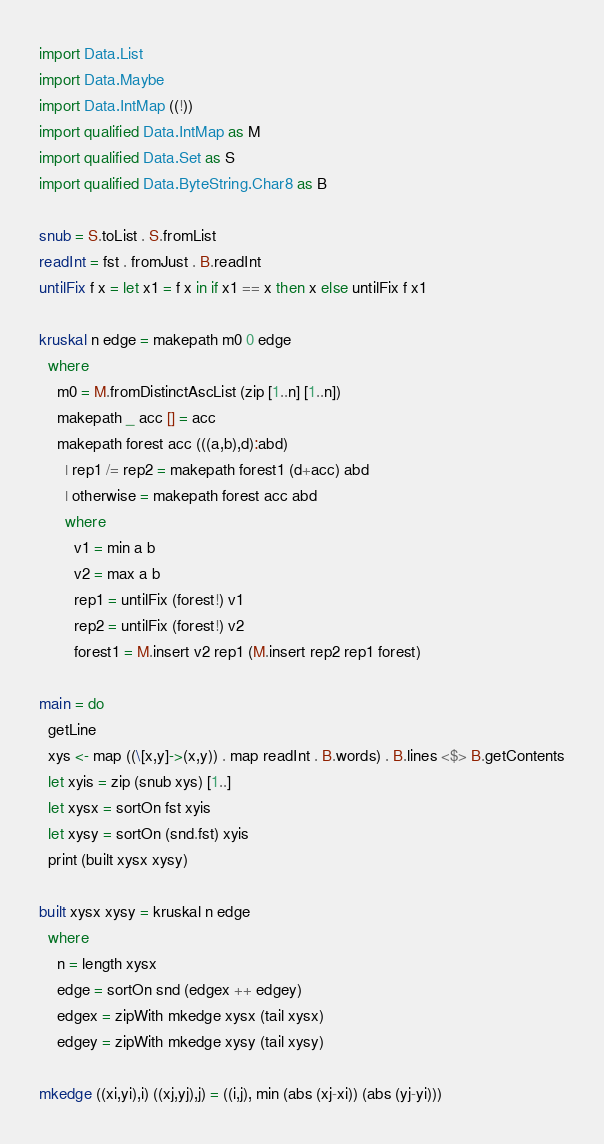Convert code to text. <code><loc_0><loc_0><loc_500><loc_500><_Haskell_>import Data.List
import Data.Maybe
import Data.IntMap ((!))
import qualified Data.IntMap as M
import qualified Data.Set as S
import qualified Data.ByteString.Char8 as B

snub = S.toList . S.fromList
readInt = fst . fromJust . B.readInt
untilFix f x = let x1 = f x in if x1 == x then x else untilFix f x1

kruskal n edge = makepath m0 0 edge
  where
    m0 = M.fromDistinctAscList (zip [1..n] [1..n])
    makepath _ acc [] = acc
    makepath forest acc (((a,b),d):abd)
      | rep1 /= rep2 = makepath forest1 (d+acc) abd
      | otherwise = makepath forest acc abd
      where
        v1 = min a b
        v2 = max a b
        rep1 = untilFix (forest!) v1
        rep2 = untilFix (forest!) v2
        forest1 = M.insert v2 rep1 (M.insert rep2 rep1 forest)

main = do
  getLine
  xys <- map ((\[x,y]->(x,y)) . map readInt . B.words) . B.lines <$> B.getContents
  let xyis = zip (snub xys) [1..]
  let xysx = sortOn fst xyis
  let xysy = sortOn (snd.fst) xyis
  print (built xysx xysy)

built xysx xysy = kruskal n edge
  where
    n = length xysx
    edge = sortOn snd (edgex ++ edgey)
    edgex = zipWith mkedge xysx (tail xysx)
    edgey = zipWith mkedge xysy (tail xysy)

mkedge ((xi,yi),i) ((xj,yj),j) = ((i,j), min (abs (xj-xi)) (abs (yj-yi)))
</code> 